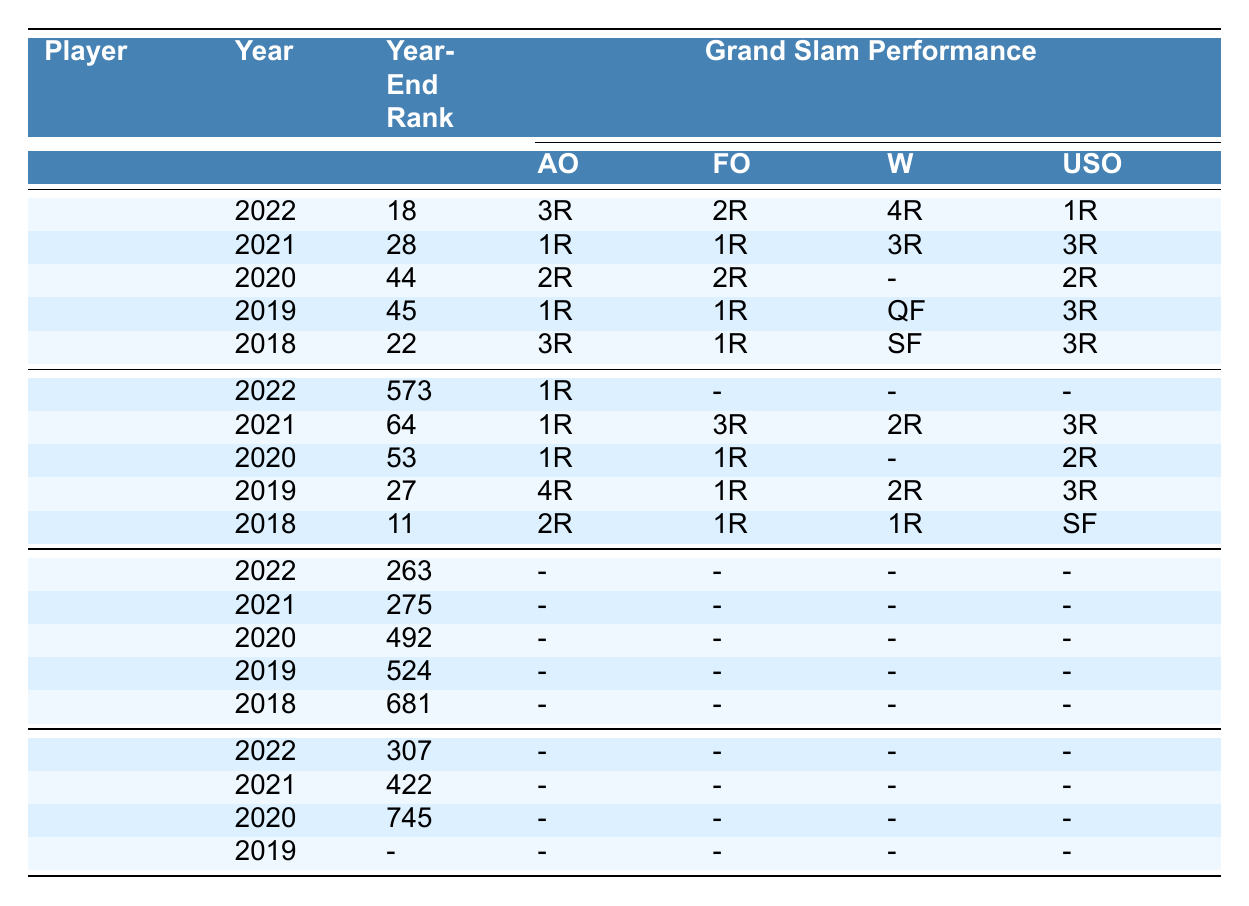What was Jeļena Ostapenko's highest ranking in 2022? According to the table, Jeļena Ostapenko had her highest ranking of 12 in 2022.
Answer: 12 In which Grand Slam did Anastasija Sevastova reach the farthest in 2021? In 2021, Anastasija Sevastova reached the 3rd Round in both the French Open and the US Open, which are the farthest she advanced that year.
Answer: French Open and US Open What is the year-end ranking of Darja Semeņistaja in 2020? The table shows that Darja Semeņistaja had a year-end ranking of 745 in 2020.
Answer: 745 How many Grand Slams did Daniela Vismane qualify for in 2022? The table indicates that Daniela Vismane did not qualify for any Grand Slams in 2022, as it states "Did not qualify" for each event.
Answer: 0 What was the difference between Anastasija Sevastova's year-end ranking in 2018 and 2021? In 2018, Anastasija Sevastova's year-end ranking was 11, and in 2021 it was 64. The difference is 64 - 11 = 53.
Answer: 53 Did Jeļena Ostapenko perform better at the Australian Open in 2019 or 2020? In 2019, Jeļena Ostapenko reached the 1st Round, while in 2020, she reached the 2nd Round. Since 2nd Round is further than 1st Round, she performed better in 2020.
Answer: Yes, she performed better in 2020 What is the average year-end ranking of all listed Latvian players in 2022? The year-end rankings are 18 (Ostapenko), 573 (Sevastova), 263 (Vismane), and 307 (Semeņistaja). The average is (18 + 573 + 263 + 307)/4 = 290.25.
Answer: 290.25 Which player had the highest Grand Slam performance in 2019? Anastasija Sevastova had the highest performance in 2019, reaching the 4th Round in the Australian Open.
Answer: Anastasija Sevastova Was there a year when all players listed did not qualify for any Grand Slam? Yes, in 2022, all listed players had "Did not qualify" for their Grand Slam performances, indicating none qualified that year.
Answer: Yes How many players had a year-end ranking below 300 in 2021? Analyzing the rankings for 2021: Jeļena Ostapenko (28), Anastasija Sevastova (64), Daniela Vismane (275), and Darja Semeņistaja (422). Two players, Vismane (275) and Ostapenko (28), had rankings below 300.
Answer: 2 